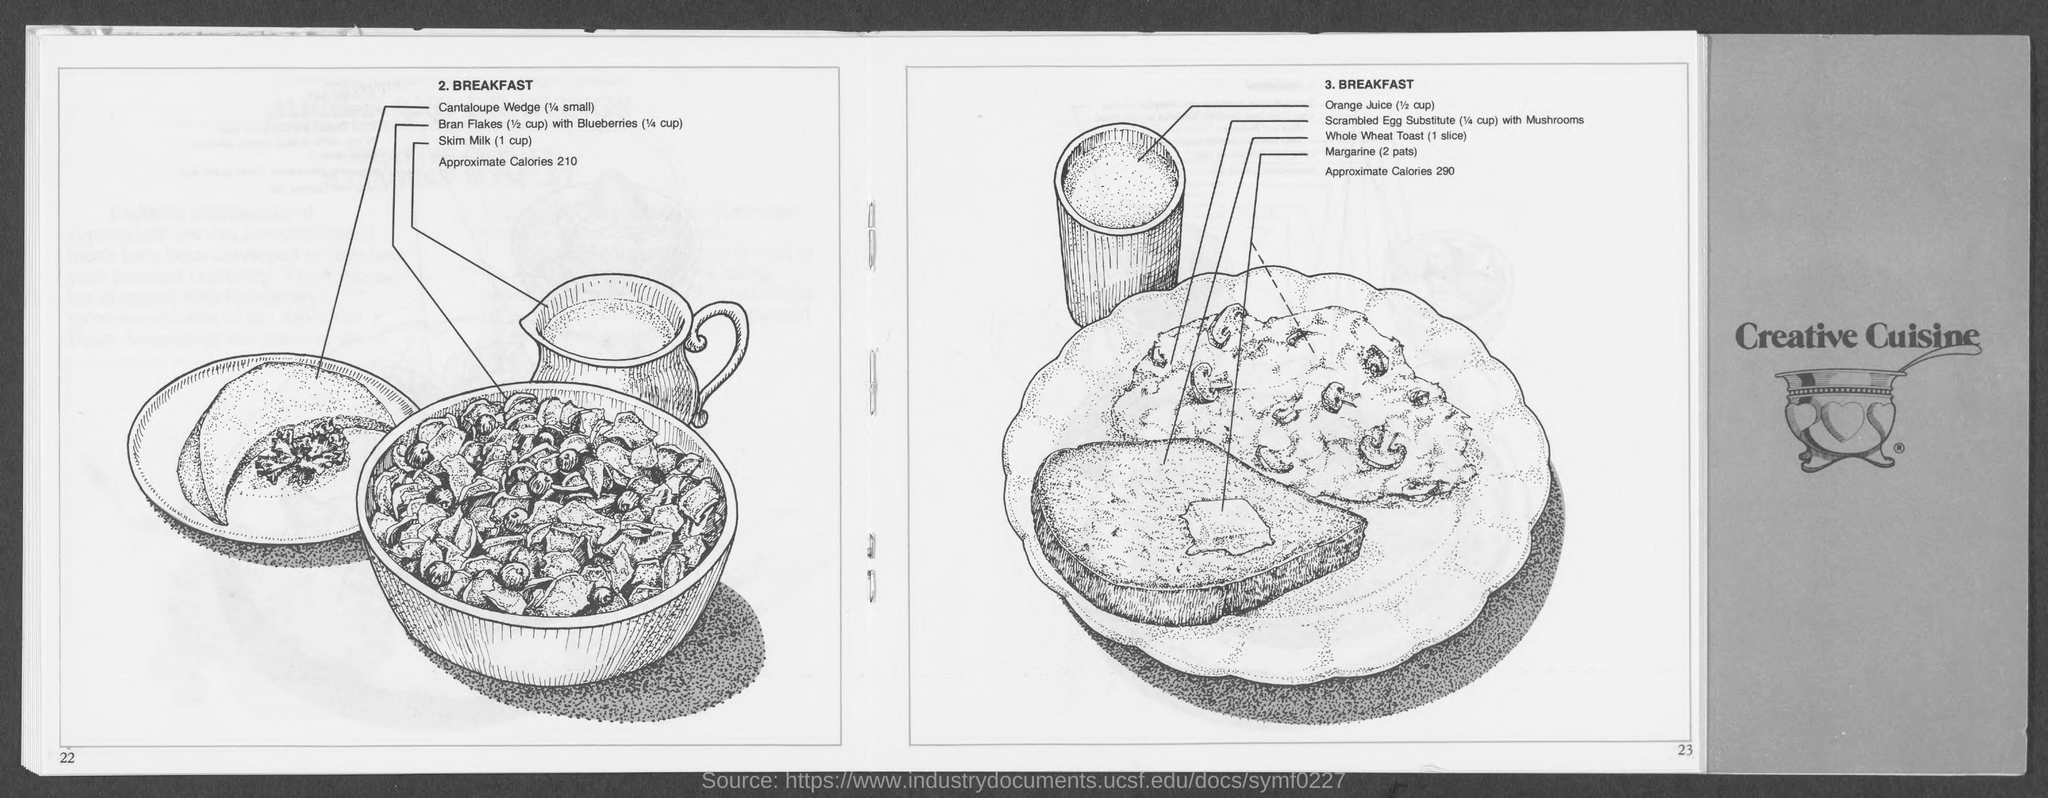Outline some significant characteristics in this image. It is recommended to consume one slice of whole wheat toast under point 3. The approximate caloric value of breakfast, as mentioned in point 2, is 210. According to point number 3, the approximate calories of breakfast are 290. 